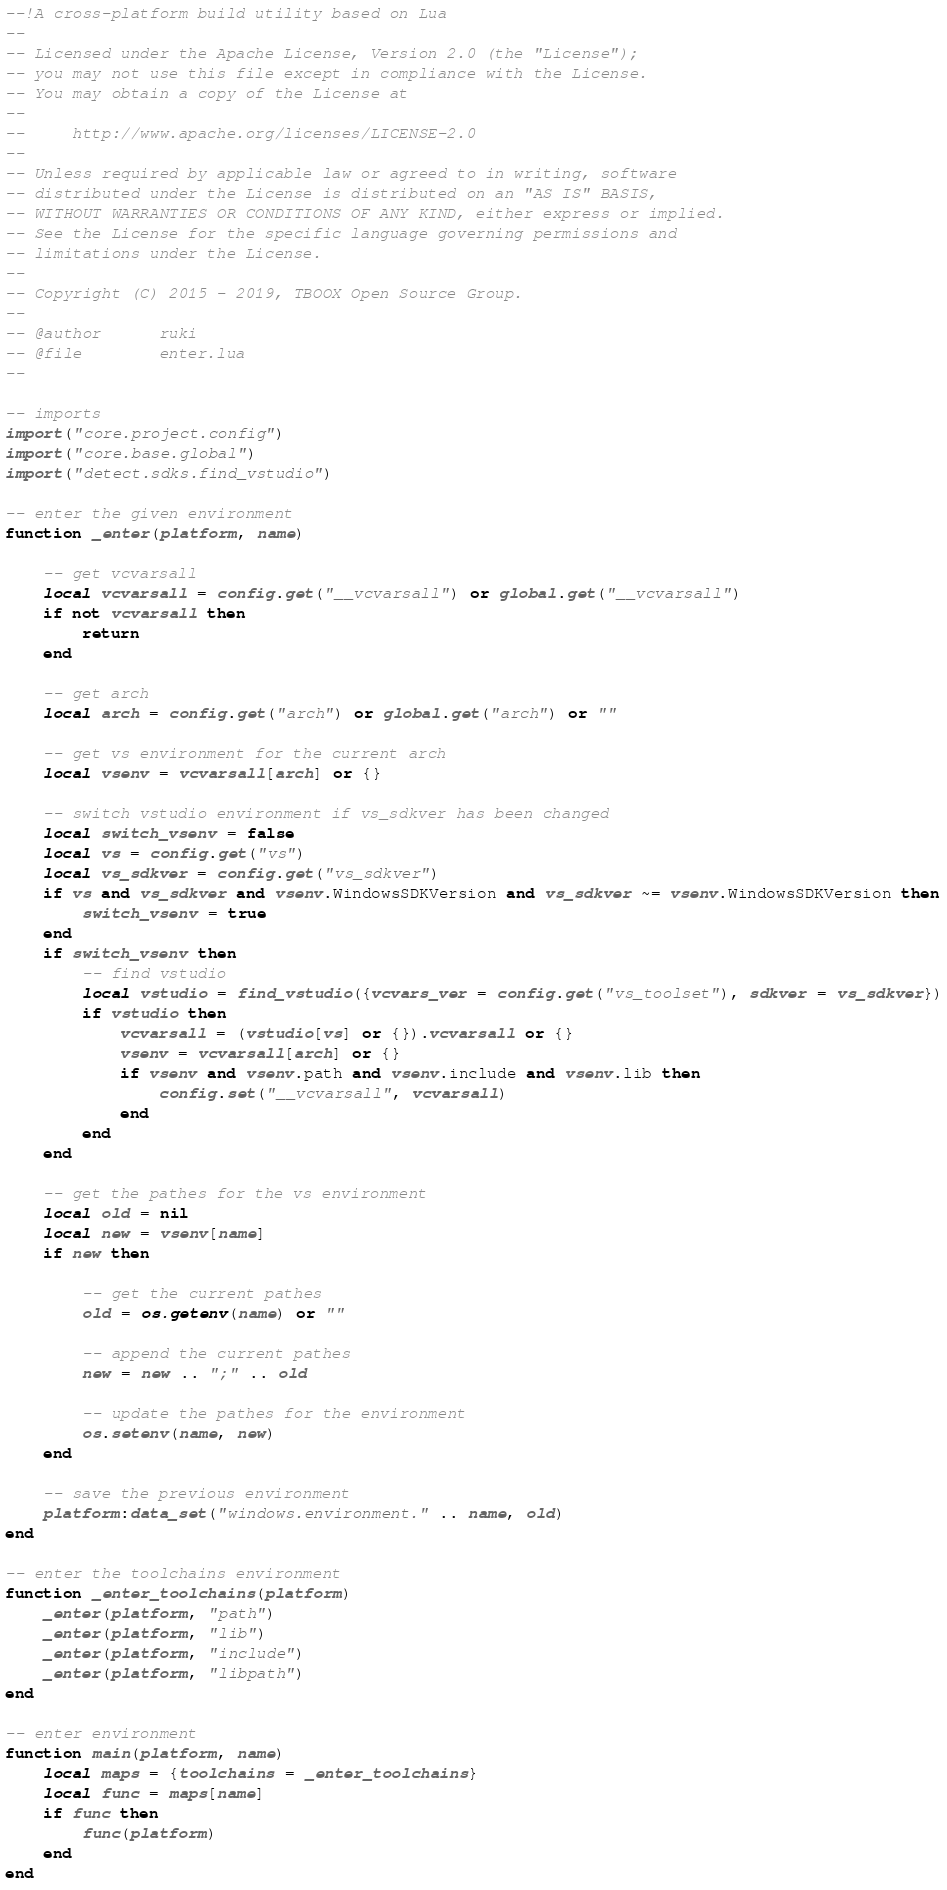Convert code to text. <code><loc_0><loc_0><loc_500><loc_500><_Lua_>--!A cross-platform build utility based on Lua
--
-- Licensed under the Apache License, Version 2.0 (the "License");
-- you may not use this file except in compliance with the License.
-- You may obtain a copy of the License at
--
--     http://www.apache.org/licenses/LICENSE-2.0
--
-- Unless required by applicable law or agreed to in writing, software
-- distributed under the License is distributed on an "AS IS" BASIS,
-- WITHOUT WARRANTIES OR CONDITIONS OF ANY KIND, either express or implied.
-- See the License for the specific language governing permissions and
-- limitations under the License.
-- 
-- Copyright (C) 2015 - 2019, TBOOX Open Source Group.
--
-- @author      ruki
-- @file        enter.lua
--

-- imports
import("core.project.config")
import("core.base.global")
import("detect.sdks.find_vstudio")

-- enter the given environment
function _enter(platform, name)

    -- get vcvarsall
    local vcvarsall = config.get("__vcvarsall") or global.get("__vcvarsall")
    if not vcvarsall then
        return 
    end

    -- get arch
    local arch = config.get("arch") or global.get("arch") or ""

    -- get vs environment for the current arch
    local vsenv = vcvarsall[arch] or {}

    -- switch vstudio environment if vs_sdkver has been changed 
    local switch_vsenv = false
    local vs = config.get("vs")
    local vs_sdkver = config.get("vs_sdkver")
    if vs and vs_sdkver and vsenv.WindowsSDKVersion and vs_sdkver ~= vsenv.WindowsSDKVersion then
        switch_vsenv = true
    end
    if switch_vsenv then
        -- find vstudio
        local vstudio = find_vstudio({vcvars_ver = config.get("vs_toolset"), sdkver = vs_sdkver})
        if vstudio then
            vcvarsall = (vstudio[vs] or {}).vcvarsall or {}
            vsenv = vcvarsall[arch] or {}
            if vsenv and vsenv.path and vsenv.include and vsenv.lib then
                config.set("__vcvarsall", vcvarsall)
            end
        end
    end

    -- get the pathes for the vs environment
    local old = nil
    local new = vsenv[name]
    if new then

        -- get the current pathes
        old = os.getenv(name) or ""

        -- append the current pathes
        new = new .. ";" .. old

        -- update the pathes for the environment
        os.setenv(name, new)
    end

    -- save the previous environment
    platform:data_set("windows.environment." .. name, old)
end

-- enter the toolchains environment
function _enter_toolchains(platform)
    _enter(platform, "path")
    _enter(platform, "lib")
    _enter(platform, "include")
    _enter(platform, "libpath")
end

-- enter environment
function main(platform, name)
    local maps = {toolchains = _enter_toolchains}
    local func = maps[name]
    if func then
        func(platform)
    end
end

</code> 